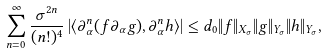<formula> <loc_0><loc_0><loc_500><loc_500>\sum _ { n = 0 } ^ { \infty } \frac { \sigma ^ { 2 n } } { ( n ! ) ^ { 4 } } \left | \langle \partial _ { \alpha } ^ { n } ( f \partial _ { \alpha } g ) , \partial _ { \alpha } ^ { n } h \rangle \right | \leq d _ { 0 } \| f \| _ { X _ { \sigma } } \| g \| _ { Y _ { \sigma } } \| h \| _ { Y _ { \sigma } } ,</formula> 